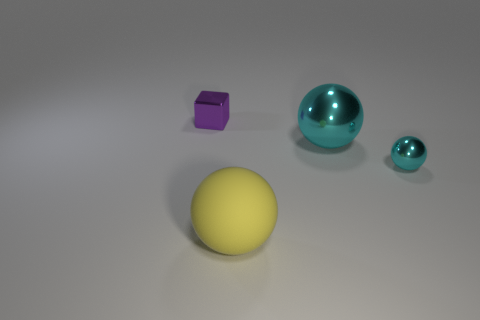Subtract all cyan spheres. How many were subtracted if there are1cyan spheres left? 1 Subtract all large balls. How many balls are left? 1 Add 3 yellow cylinders. How many objects exist? 7 Subtract all cyan balls. How many balls are left? 1 Subtract 2 balls. How many balls are left? 1 Subtract all red blocks. Subtract all cyan cylinders. How many blocks are left? 1 Subtract all purple cubes. How many brown balls are left? 0 Subtract all tiny yellow rubber cubes. Subtract all tiny cyan metal balls. How many objects are left? 3 Add 4 yellow spheres. How many yellow spheres are left? 5 Add 4 large metal objects. How many large metal objects exist? 5 